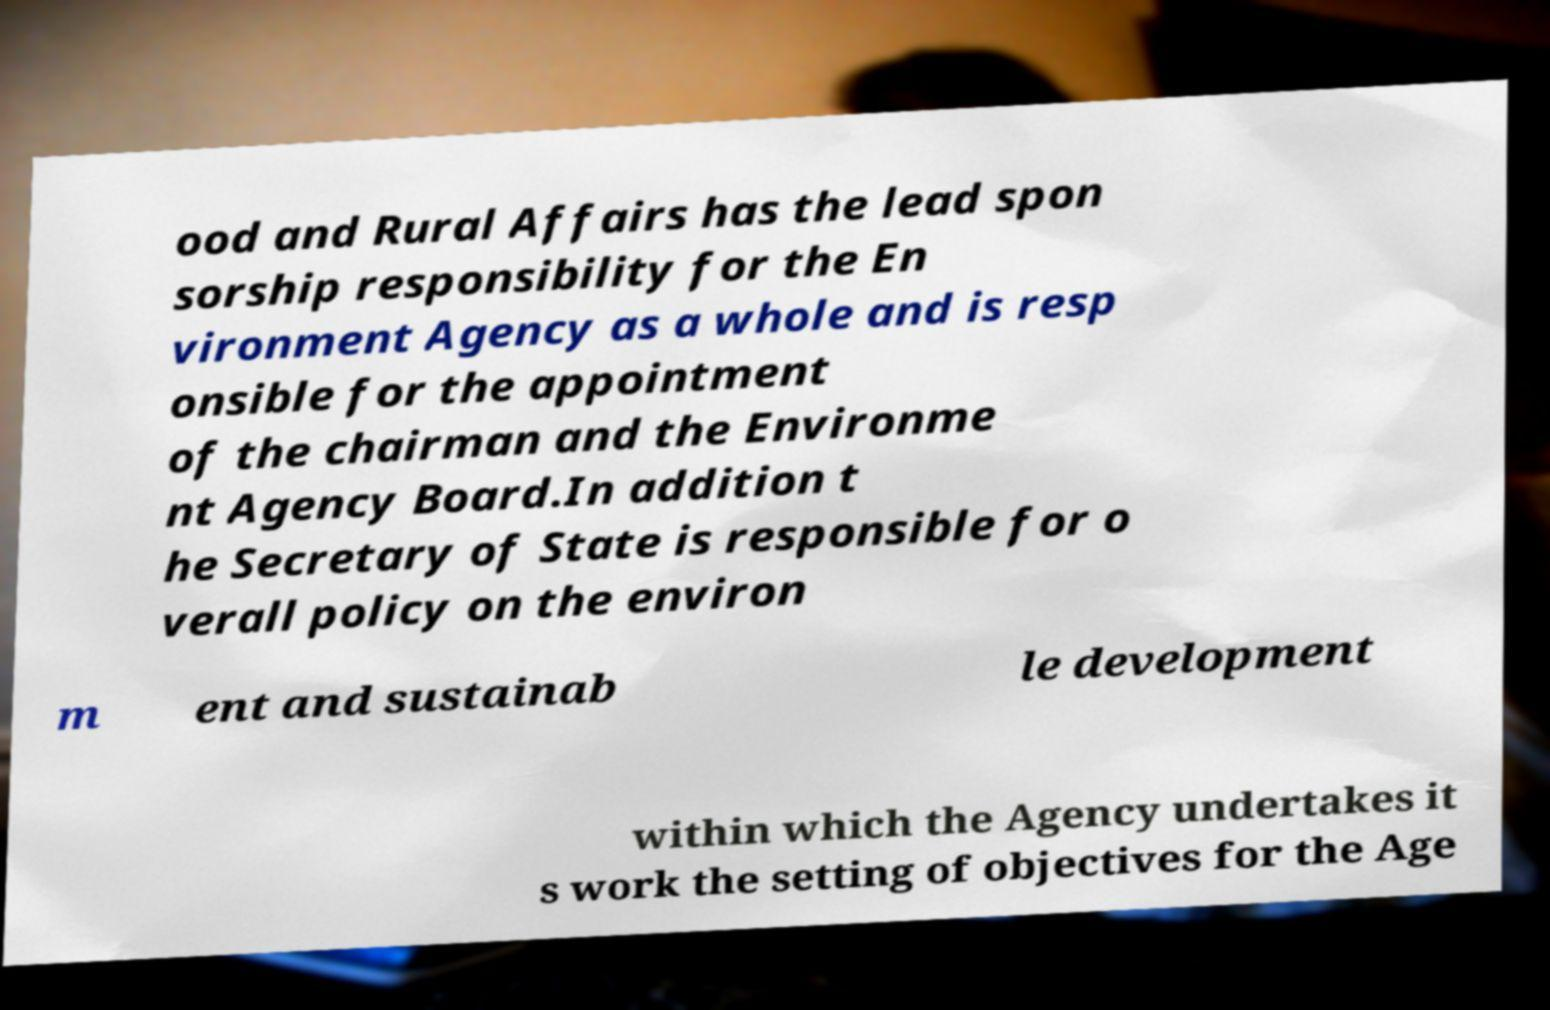Could you assist in decoding the text presented in this image and type it out clearly? ood and Rural Affairs has the lead spon sorship responsibility for the En vironment Agency as a whole and is resp onsible for the appointment of the chairman and the Environme nt Agency Board.In addition t he Secretary of State is responsible for o verall policy on the environ m ent and sustainab le development within which the Agency undertakes it s work the setting of objectives for the Age 